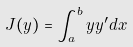<formula> <loc_0><loc_0><loc_500><loc_500>J ( y ) = \int _ { a } ^ { b } y y ^ { \prime } d x</formula> 